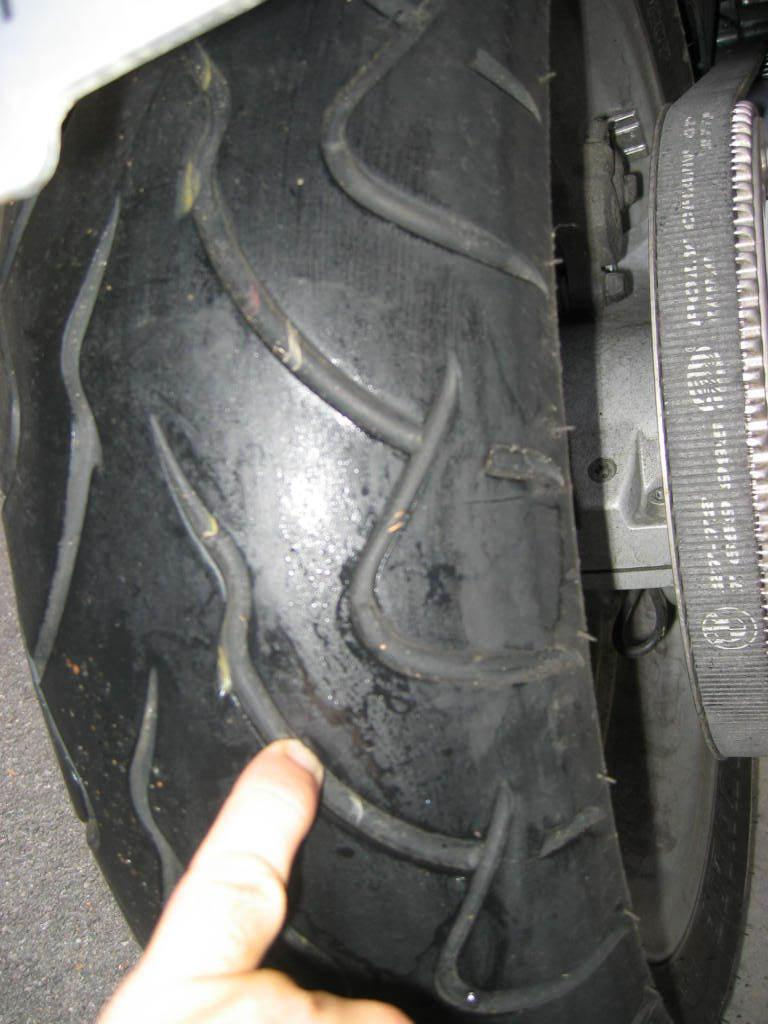What object is present in the image that is typically used on vehicles? There is a tire in the image. What part of the human body is visible in the image? A human finger is visible in the image. What type of roof is visible in the image? There is no roof present in the image. What is the dad doing in the image? There is no dad present in the image. What book is being read in the image? There is no book present in the image. 